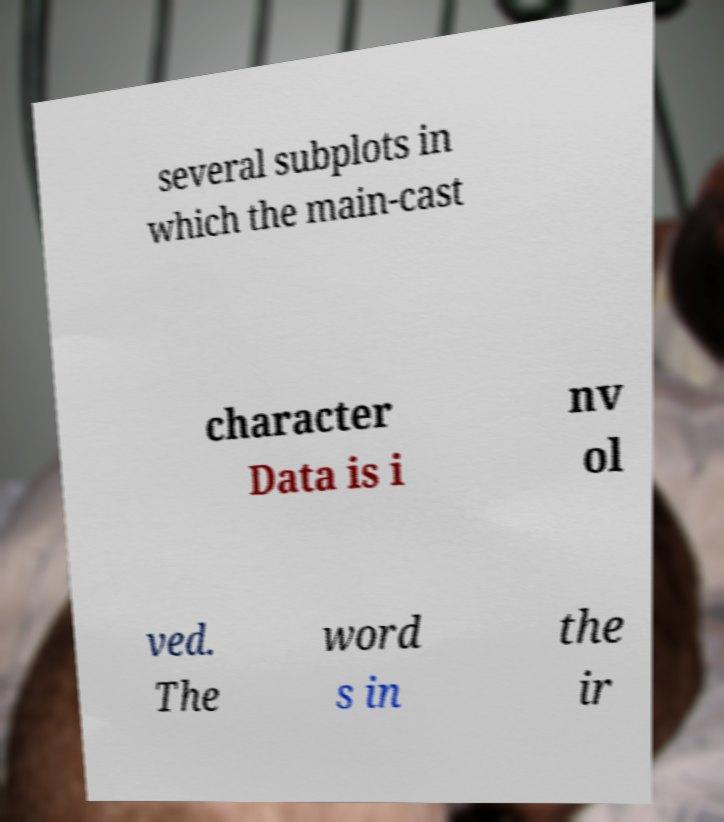Please read and relay the text visible in this image. What does it say? several subplots in which the main-cast character Data is i nv ol ved. The word s in the ir 